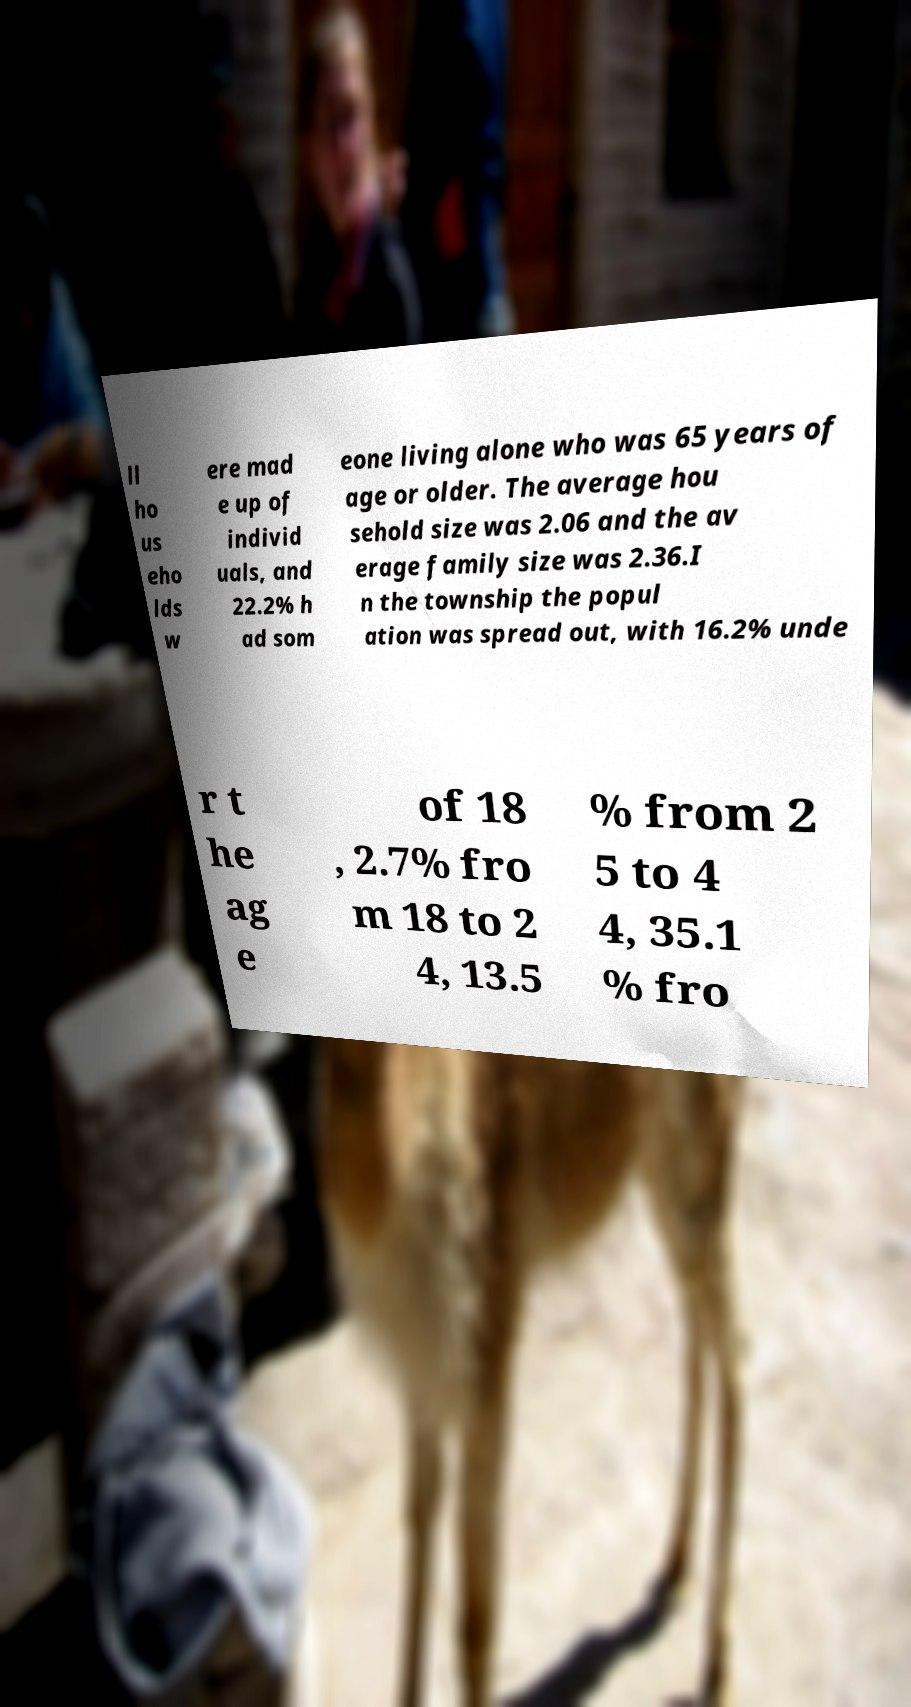Could you extract and type out the text from this image? ll ho us eho lds w ere mad e up of individ uals, and 22.2% h ad som eone living alone who was 65 years of age or older. The average hou sehold size was 2.06 and the av erage family size was 2.36.I n the township the popul ation was spread out, with 16.2% unde r t he ag e of 18 , 2.7% fro m 18 to 2 4, 13.5 % from 2 5 to 4 4, 35.1 % fro 